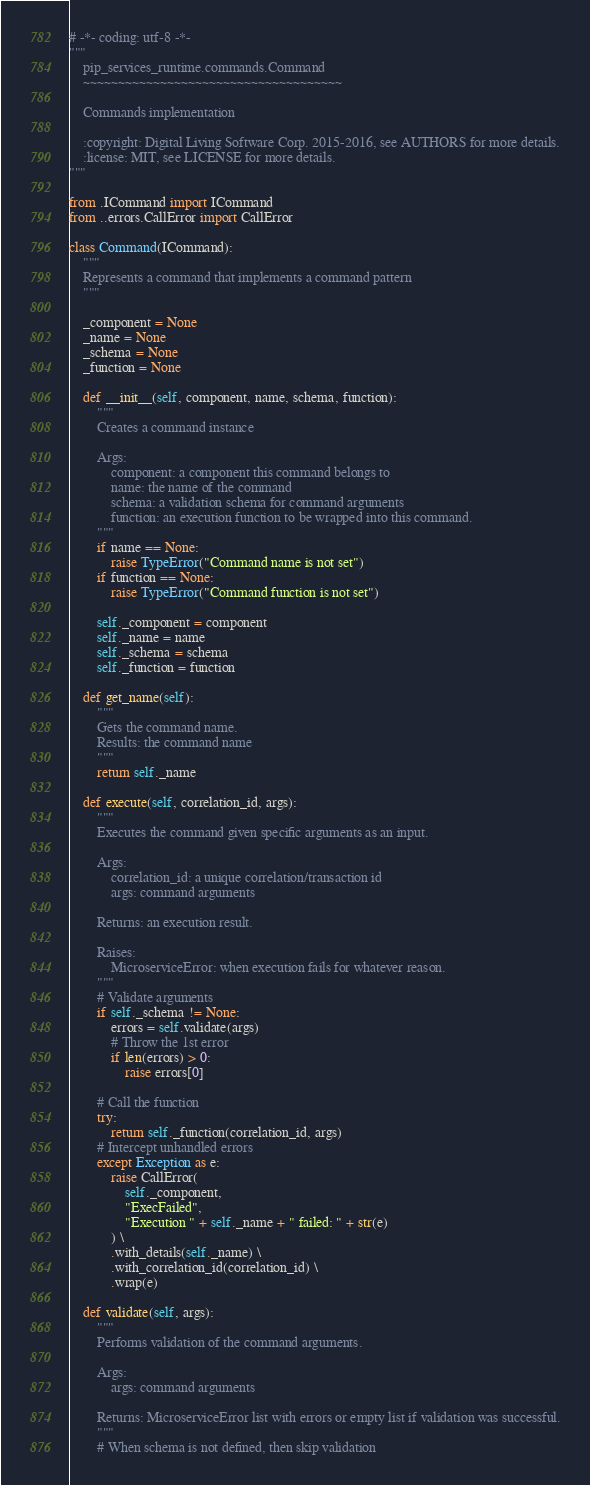<code> <loc_0><loc_0><loc_500><loc_500><_Python_># -*- coding: utf-8 -*-
"""
    pip_services_runtime.commands.Command
    ~~~~~~~~~~~~~~~~~~~~~~~~~~~~~~~~~~~~~
    
    Commands implementation
    
    :copyright: Digital Living Software Corp. 2015-2016, see AUTHORS for more details.
    :license: MIT, see LICENSE for more details.
"""

from .ICommand import ICommand
from ..errors.CallError import CallError

class Command(ICommand):
    """
    Represents a command that implements a command pattern
    """

    _component = None
    _name = None
    _schema = None
    _function = None

    def __init__(self, component, name, schema, function):
        """
        Creates a command instance
        
        Args:
            component: a component this command belongs to
            name: the name of the command
            schema: a validation schema for command arguments
            function: an execution function to be wrapped into this command.
        """
        if name == None:
            raise TypeError("Command name is not set")
        if function == None:
            raise TypeError("Command function is not set")
        
        self._component = component
        self._name = name
        self._schema = schema
        self._function = function

    def get_name(self):
        """
        Gets the command name.
        Results: the command name
        """
        return self._name

    def execute(self, correlation_id, args):
        """
        Executes the command given specific arguments as an input.
        
        Args:
            correlation_id: a unique correlation/transaction id
            args: command arguments
        
        Returns: an execution result.
        
        Raises:
            MicroserviceError: when execution fails for whatever reason.
        """
        # Validate arguments
        if self._schema != None:
            errors = self.validate(args)
            # Throw the 1st error
            if len(errors) > 0:
                raise errors[0]
        
        # Call the function
        try:
            return self._function(correlation_id, args)
        # Intercept unhandled errors
        except Exception as e:
            raise CallError(
                self._component,
                "ExecFailed",
                "Execution " + self._name + " failed: " + str(e)
            ) \
            .with_details(self._name) \
            .with_correlation_id(correlation_id) \
            .wrap(e)

    def validate(self, args):
        """
        Performs validation of the command arguments.
        
        Args:
            args: command arguments
        
        Returns: MicroserviceError list with errors or empty list if validation was successful.
        """
        # When schema is not defined, then skip validation</code> 